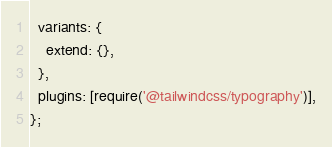<code> <loc_0><loc_0><loc_500><loc_500><_JavaScript_>  variants: {
    extend: {},
  },
  plugins: [require('@tailwindcss/typography')],
};
</code> 